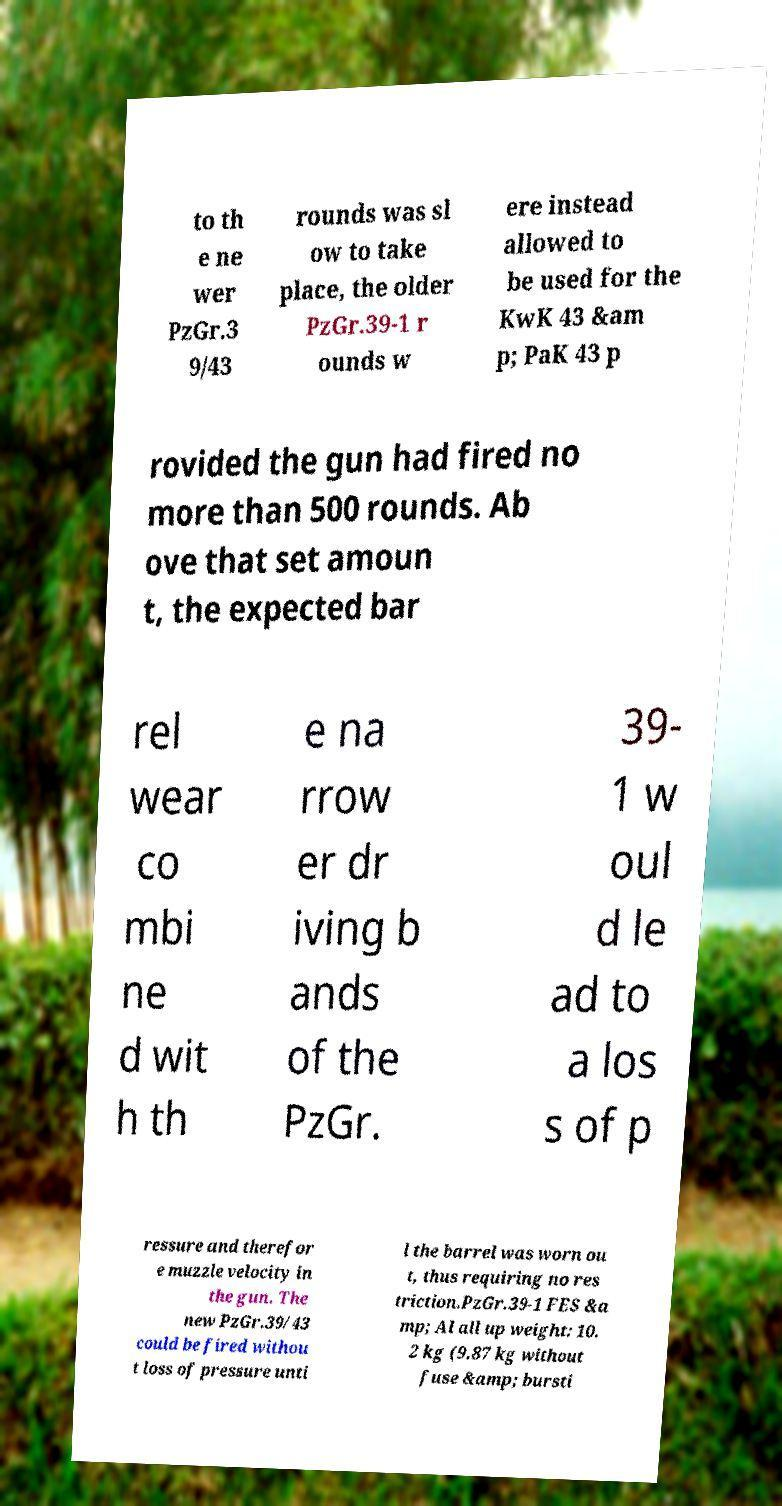There's text embedded in this image that I need extracted. Can you transcribe it verbatim? to th e ne wer PzGr.3 9/43 rounds was sl ow to take place, the older PzGr.39-1 r ounds w ere instead allowed to be used for the KwK 43 &am p; PaK 43 p rovided the gun had fired no more than 500 rounds. Ab ove that set amoun t, the expected bar rel wear co mbi ne d wit h th e na rrow er dr iving b ands of the PzGr. 39- 1 w oul d le ad to a los s of p ressure and therefor e muzzle velocity in the gun. The new PzGr.39/43 could be fired withou t loss of pressure unti l the barrel was worn ou t, thus requiring no res triction.PzGr.39-1 FES &a mp; Al all up weight: 10. 2 kg (9.87 kg without fuse &amp; bursti 